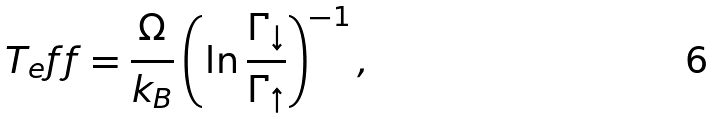<formula> <loc_0><loc_0><loc_500><loc_500>T _ { e } f f = \frac { \Omega } { k _ { B } } \left ( \ln \frac { \Gamma _ { \downarrow } } { \Gamma _ { \uparrow } } \right ) ^ { - 1 } ,</formula> 